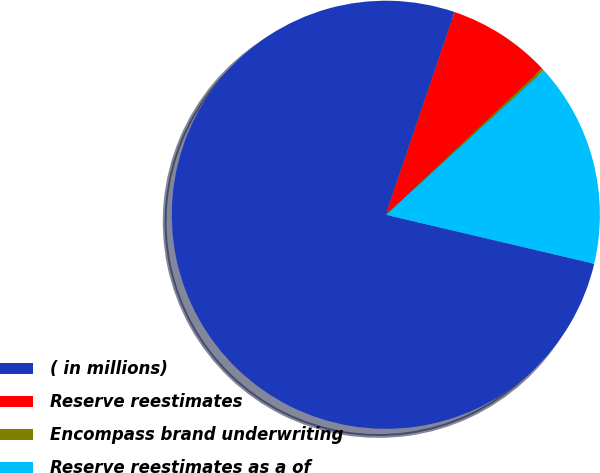<chart> <loc_0><loc_0><loc_500><loc_500><pie_chart><fcel>( in millions)<fcel>Reserve reestimates<fcel>Encompass brand underwriting<fcel>Reserve reestimates as a of<nl><fcel>76.53%<fcel>7.82%<fcel>0.19%<fcel>15.46%<nl></chart> 